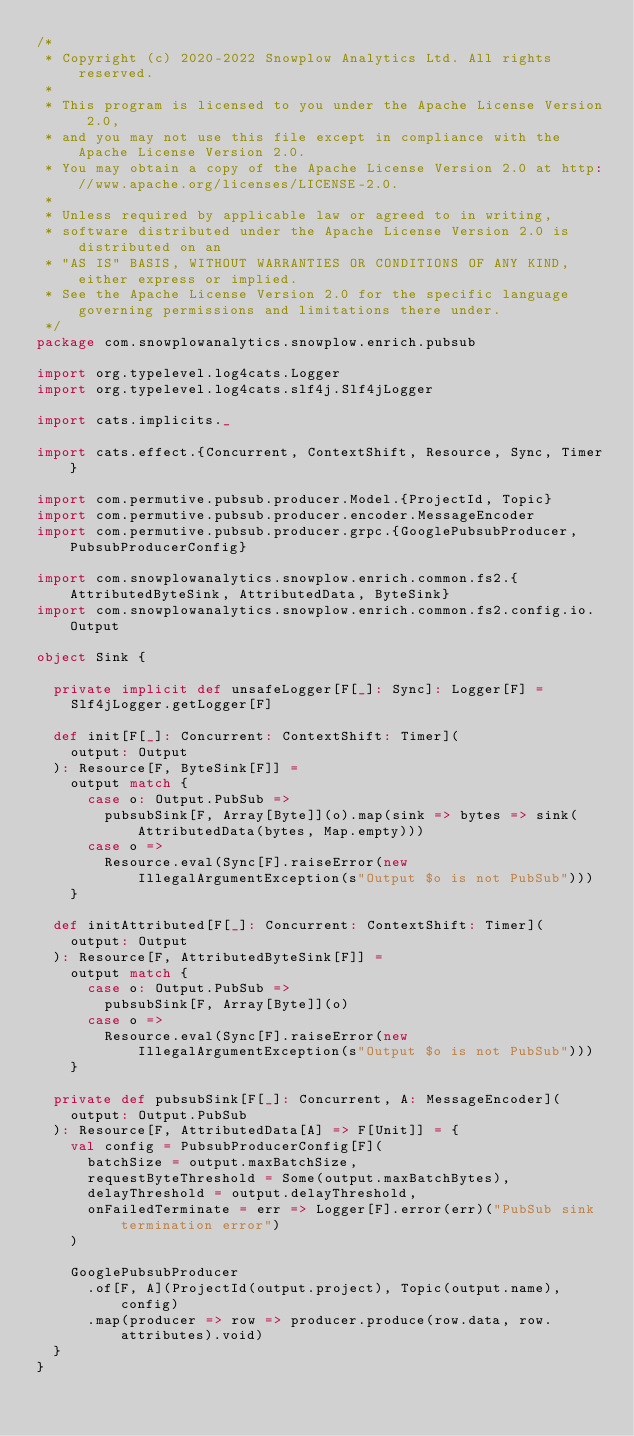Convert code to text. <code><loc_0><loc_0><loc_500><loc_500><_Scala_>/*
 * Copyright (c) 2020-2022 Snowplow Analytics Ltd. All rights reserved.
 *
 * This program is licensed to you under the Apache License Version 2.0,
 * and you may not use this file except in compliance with the Apache License Version 2.0.
 * You may obtain a copy of the Apache License Version 2.0 at http://www.apache.org/licenses/LICENSE-2.0.
 *
 * Unless required by applicable law or agreed to in writing,
 * software distributed under the Apache License Version 2.0 is distributed on an
 * "AS IS" BASIS, WITHOUT WARRANTIES OR CONDITIONS OF ANY KIND, either express or implied.
 * See the Apache License Version 2.0 for the specific language governing permissions and limitations there under.
 */
package com.snowplowanalytics.snowplow.enrich.pubsub

import org.typelevel.log4cats.Logger
import org.typelevel.log4cats.slf4j.Slf4jLogger

import cats.implicits._

import cats.effect.{Concurrent, ContextShift, Resource, Sync, Timer}

import com.permutive.pubsub.producer.Model.{ProjectId, Topic}
import com.permutive.pubsub.producer.encoder.MessageEncoder
import com.permutive.pubsub.producer.grpc.{GooglePubsubProducer, PubsubProducerConfig}

import com.snowplowanalytics.snowplow.enrich.common.fs2.{AttributedByteSink, AttributedData, ByteSink}
import com.snowplowanalytics.snowplow.enrich.common.fs2.config.io.Output

object Sink {

  private implicit def unsafeLogger[F[_]: Sync]: Logger[F] =
    Slf4jLogger.getLogger[F]

  def init[F[_]: Concurrent: ContextShift: Timer](
    output: Output
  ): Resource[F, ByteSink[F]] =
    output match {
      case o: Output.PubSub =>
        pubsubSink[F, Array[Byte]](o).map(sink => bytes => sink(AttributedData(bytes, Map.empty)))
      case o =>
        Resource.eval(Sync[F].raiseError(new IllegalArgumentException(s"Output $o is not PubSub")))
    }

  def initAttributed[F[_]: Concurrent: ContextShift: Timer](
    output: Output
  ): Resource[F, AttributedByteSink[F]] =
    output match {
      case o: Output.PubSub =>
        pubsubSink[F, Array[Byte]](o)
      case o =>
        Resource.eval(Sync[F].raiseError(new IllegalArgumentException(s"Output $o is not PubSub")))
    }

  private def pubsubSink[F[_]: Concurrent, A: MessageEncoder](
    output: Output.PubSub
  ): Resource[F, AttributedData[A] => F[Unit]] = {
    val config = PubsubProducerConfig[F](
      batchSize = output.maxBatchSize,
      requestByteThreshold = Some(output.maxBatchBytes),
      delayThreshold = output.delayThreshold,
      onFailedTerminate = err => Logger[F].error(err)("PubSub sink termination error")
    )

    GooglePubsubProducer
      .of[F, A](ProjectId(output.project), Topic(output.name), config)
      .map(producer => row => producer.produce(row.data, row.attributes).void)
  }
}
</code> 